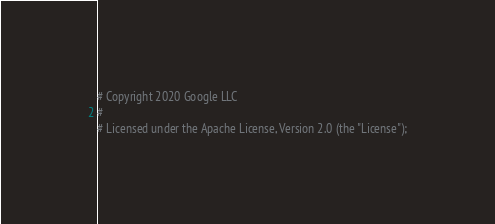<code> <loc_0><loc_0><loc_500><loc_500><_Ruby_># Copyright 2020 Google LLC
#
# Licensed under the Apache License, Version 2.0 (the "License");</code> 